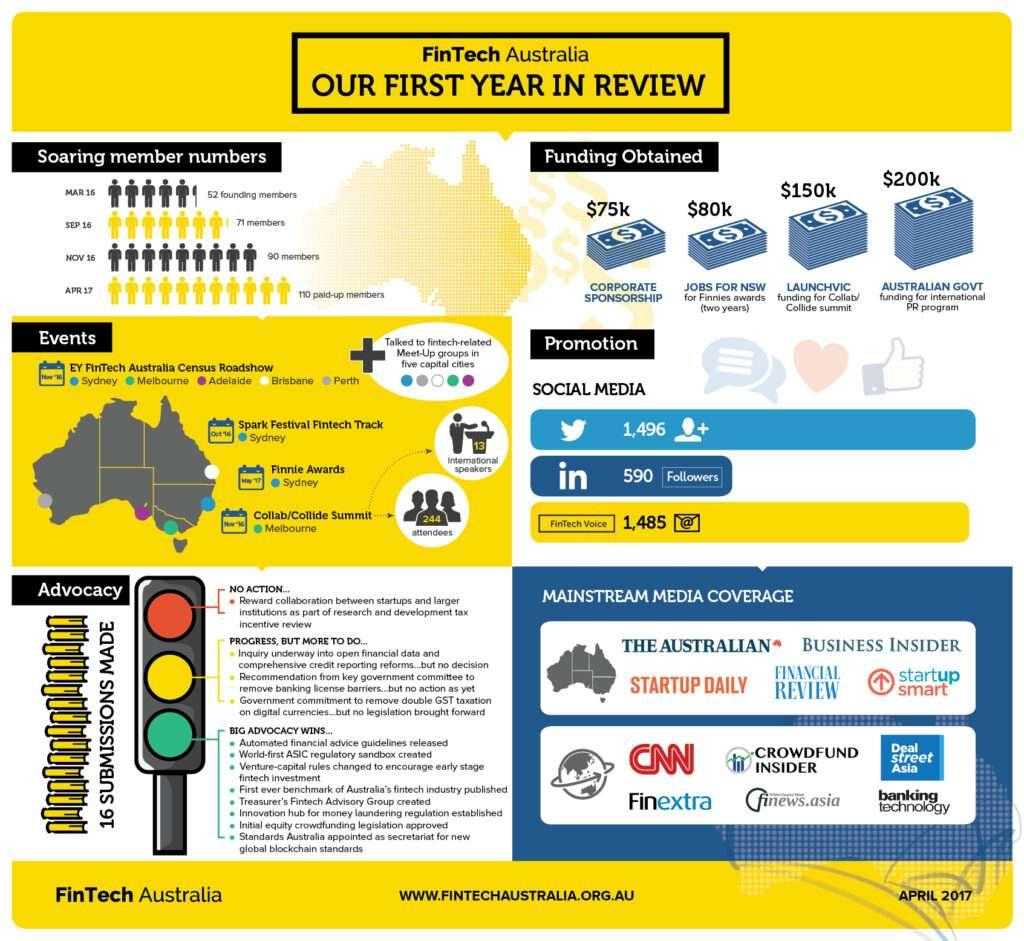Indicate a few pertinent items in this graphic. The least amount of funding was obtained from corporate sponsorship. I have 1496 followers on Twitter. Yellow denotes progress, but there is still more to be done. I have received $80,000 in funding for Finnies awards. There were 13 international speakers. 